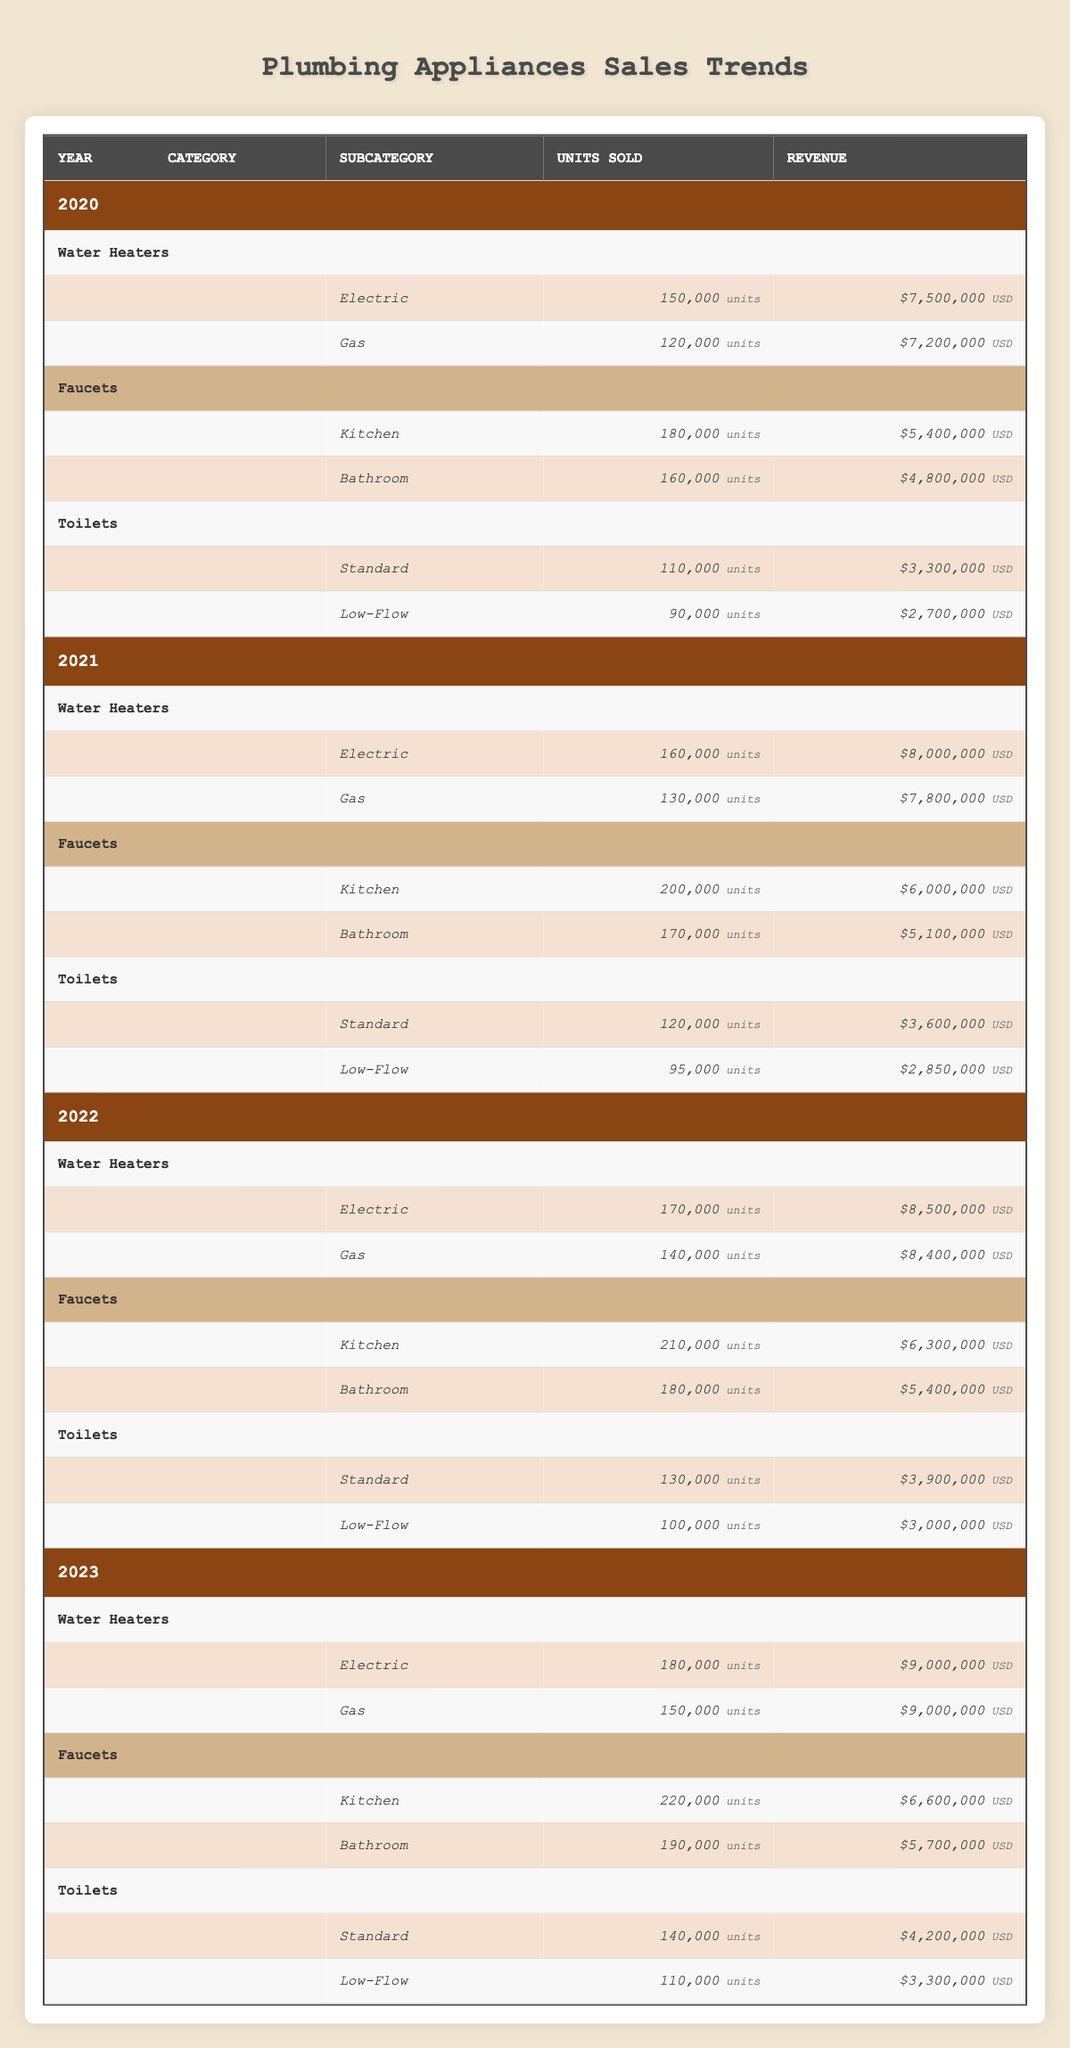What was the total revenue from Electric Water Heaters in 2021? In 2021, the revenue from Electric Water Heaters is 8,000,000.
Answer: 8,000,000 How many total units of Gas Water Heaters were sold from 2020 to 2023? The units sold each year are: 120,000 (2020) + 130,000 (2021) + 140,000 (2022) + 150,000 (2023) = 540,000.
Answer: 540,000 Did sales of Kitchen Faucets increase every year from 2020 to 2023? Yes, the units sold each year are: 180,000 (2020), 200,000 (2021), 210,000 (2022), and 220,000 (2023), showing a consistent increase.
Answer: Yes What was the average units sold for Low-Flow Toilets in 2022 and 2023? The units sold for Low-Flow Toilets are 100,000 in 2022 and 110,000 in 2023; their average is (100,000 + 110,000) / 2 = 105,000.
Answer: 105,000 Which year had the highest revenue for Faucets overall? By summing the revenue for Faucets in each year: 2020 = 5,400,000 + 4,800,000 = 10,200,000; 2021 = 6,000,000 + 5,100,000 = 11,100,000; 2022 = 6,300,000 + 5,400,000 = 11,700,000; 2023 = 6,600,000 + 5,700,000 = 12,300,000. Thus, 2023 had the highest revenue of 12,300,000.
Answer: 2023 What was the difference in units sold from Standard Toilets in 2020 compared to 2022? In 2020, units sold were 110,000 and in 2022, they were 130,000. The difference is 130,000 - 110,000 = 20,000.
Answer: 20,000 